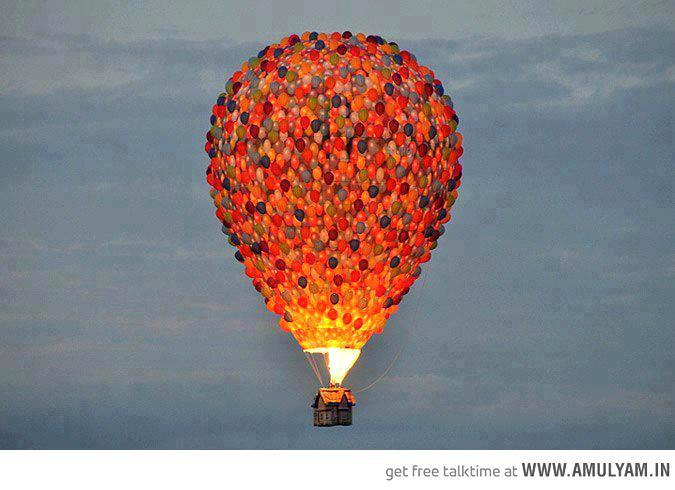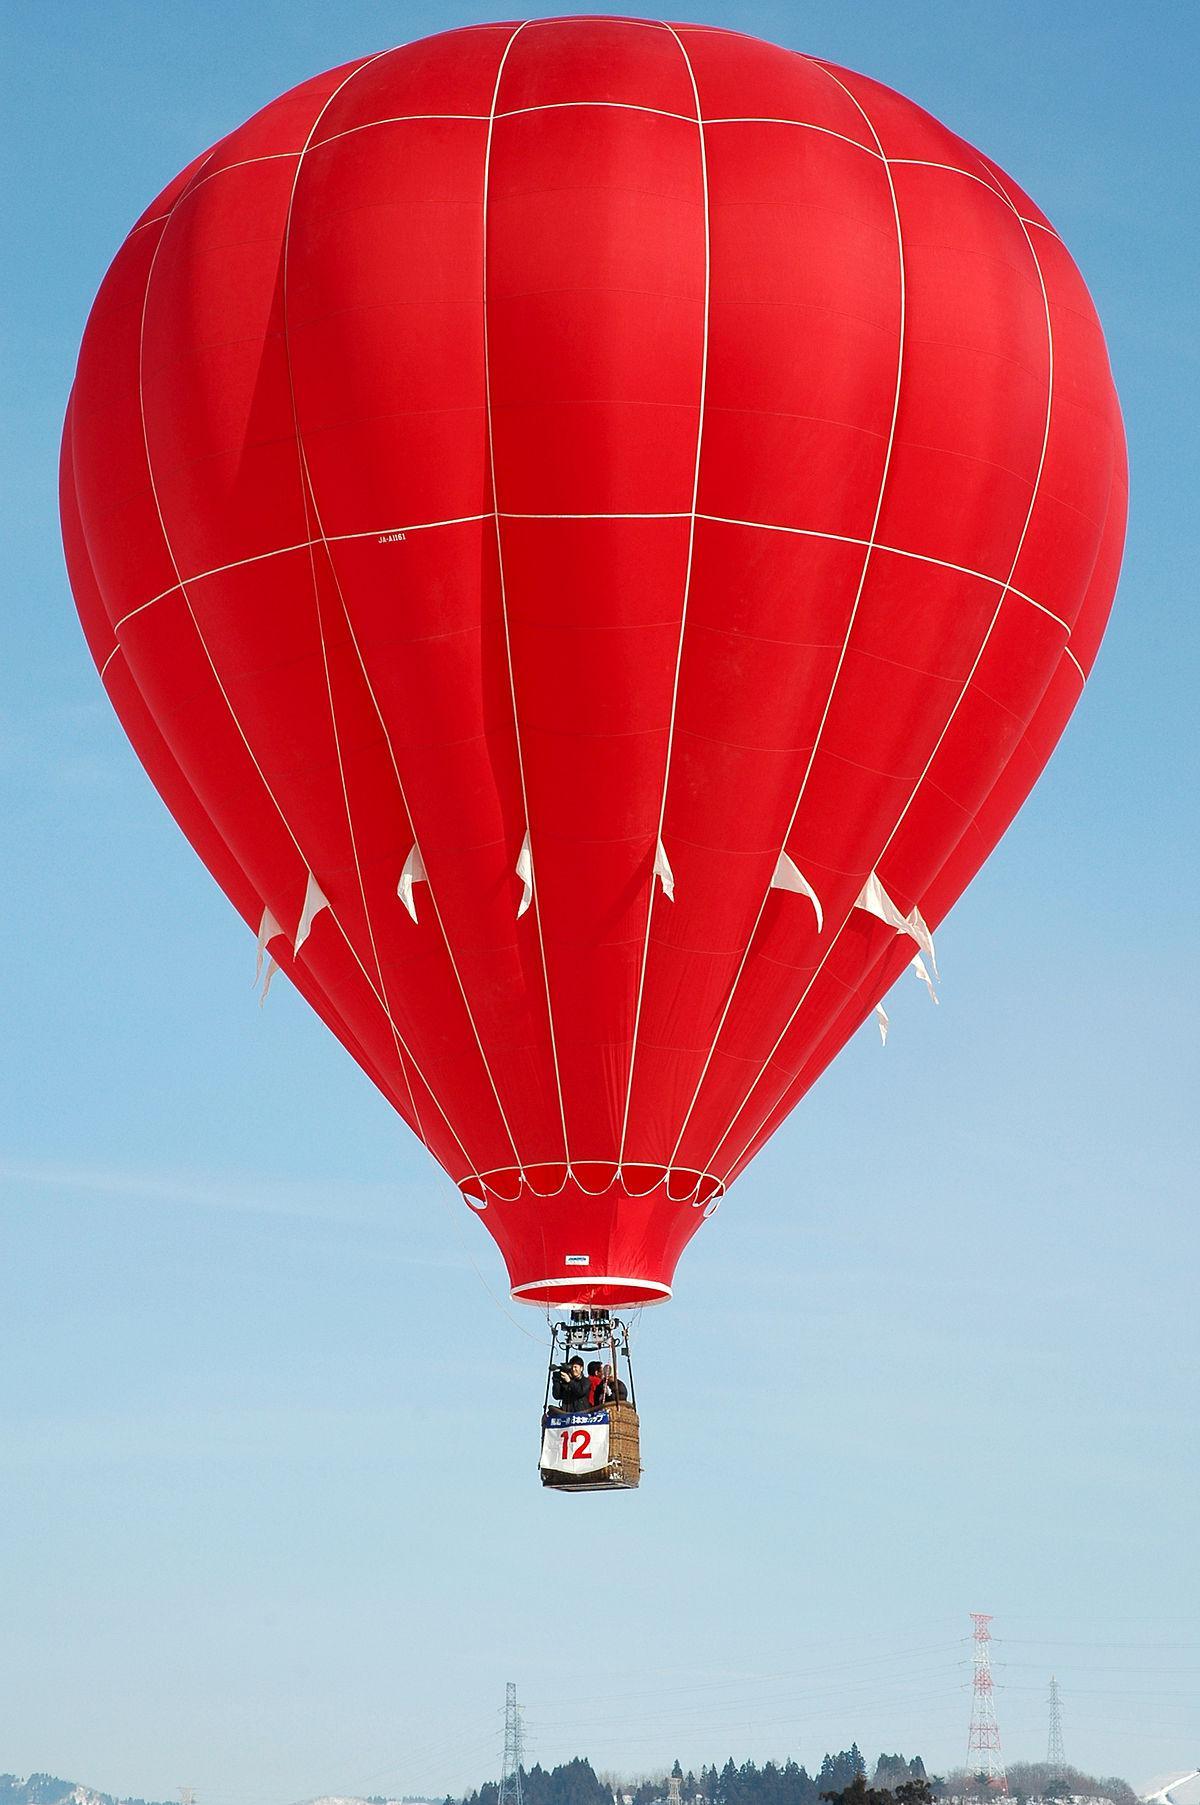The first image is the image on the left, the second image is the image on the right. Examine the images to the left and right. Is the description "One hot air balloon is sitting on a grassy area and one is floating in the air." accurate? Answer yes or no. No. 